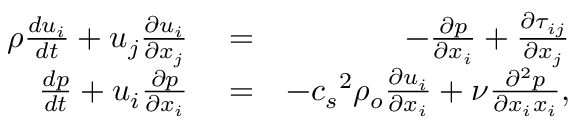Convert formula to latex. <formula><loc_0><loc_0><loc_500><loc_500>\begin{array} { r l r } { \rho \frac { d u _ { i } } { d t } + u _ { j } \frac { \partial u _ { i } } { \partial x _ { j } } } & = } & { - \frac { \partial p } { \partial x _ { i } } + \frac { \partial \tau _ { i j } } { \partial x _ { j } } } \\ { \frac { d p } { d t } + u _ { i } \frac { \partial p } { \partial x _ { i } } } & = } & { - { c _ { s } } ^ { 2 } \rho _ { o } \frac { \partial u _ { i } } { \partial x _ { i } } + \nu \frac { \partial ^ { 2 } p } { \partial x _ { i } x _ { i } } , } \end{array}</formula> 